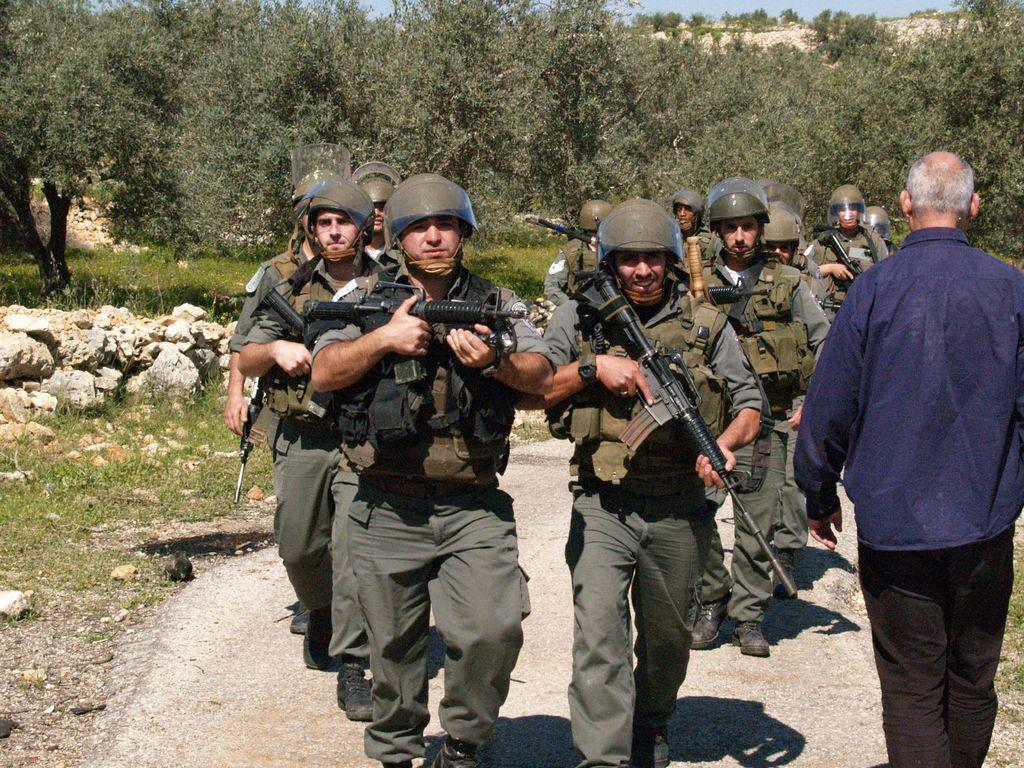What type of people can be seen in the image? There are army personnel in the image. What are the army personnel doing in the image? The army personnel are walking on a path in the image. What are the army personnel holding in the image? The army personnel are holding guns in the image. Can you describe the man in the image? There is a man wearing a blue shirt and black pants in the image. What can be seen in the background of the image? There are trees in the background of the image. What type of ground surface is visible in the image? There are stones in the image. What type of office furniture can be seen in the image? There is no office furniture present in the image; it features army personnel walking on a path. What unit are the army personnel in, as indicated by their uniforms? The image does not provide enough information to determine the specific unit of the army personnel based on their uniforms. 